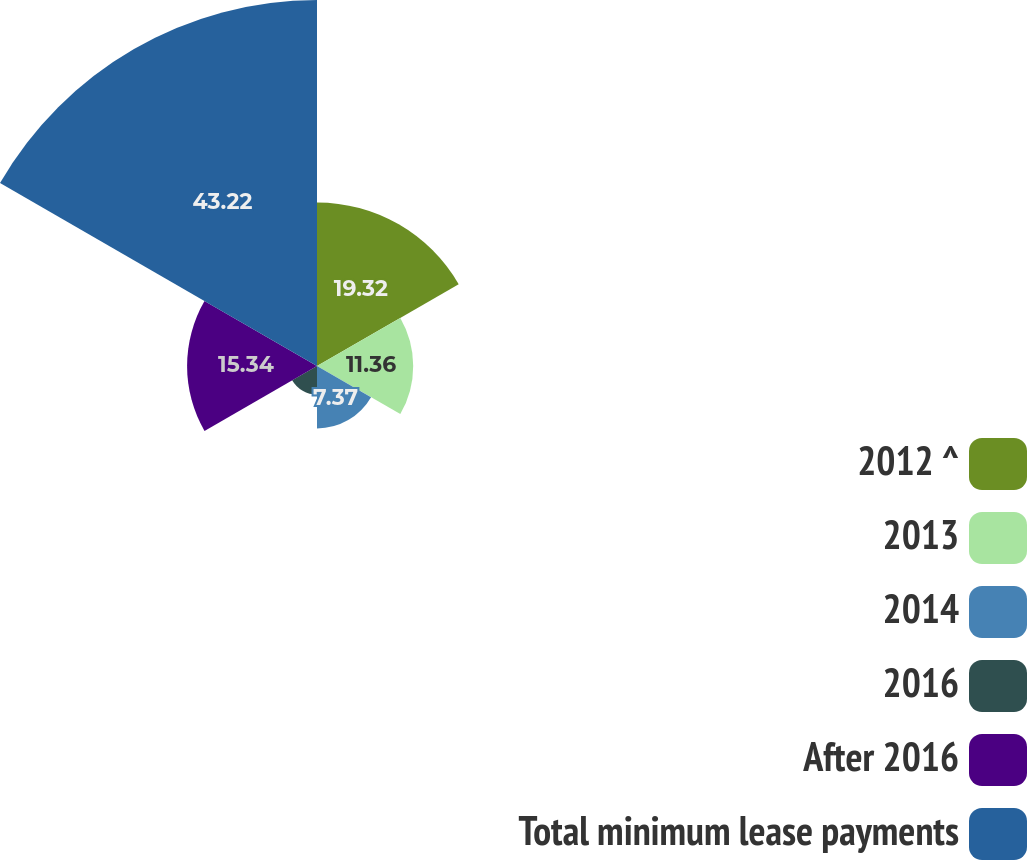Convert chart. <chart><loc_0><loc_0><loc_500><loc_500><pie_chart><fcel>2012 ^<fcel>2013<fcel>2014<fcel>2016<fcel>After 2016<fcel>Total minimum lease payments<nl><fcel>19.32%<fcel>11.36%<fcel>7.37%<fcel>3.39%<fcel>15.34%<fcel>43.22%<nl></chart> 